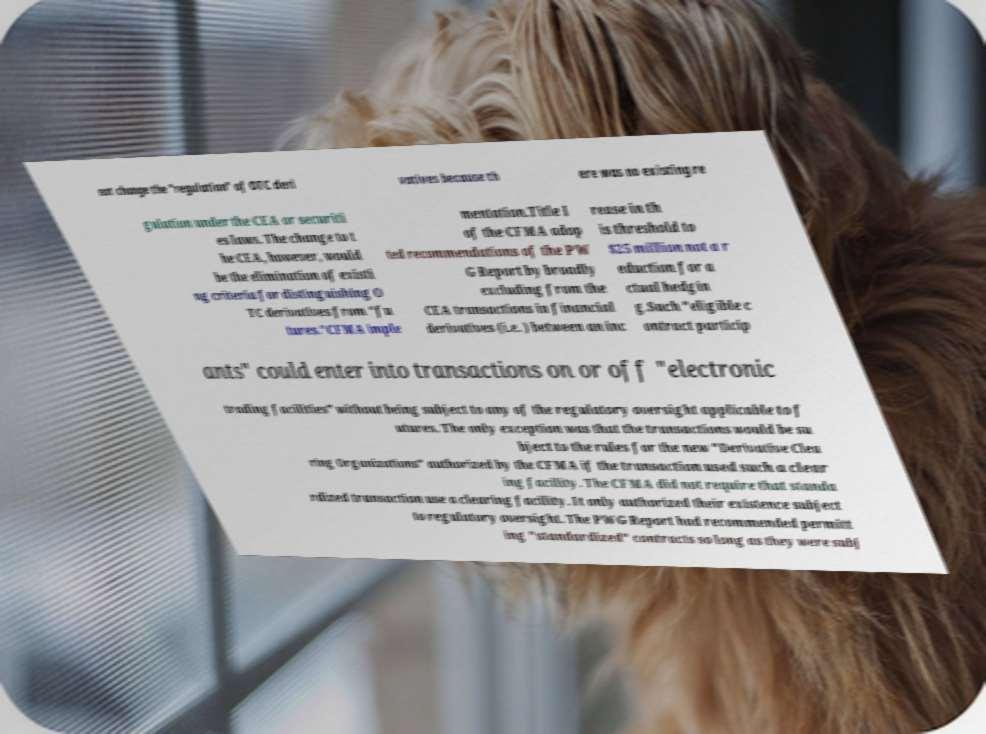What messages or text are displayed in this image? I need them in a readable, typed format. not change the "regulation" of OTC deri vatives because th ere was no existing re gulation under the CEA or securiti es laws. The change to t he CEA, however, would be the elimination of existi ng criteria for distinguishing O TC derivatives from "fu tures."CFMA imple mentation.Title I of the CFMA adop ted recommendations of the PW G Report by broadly excluding from the CEA transactions in financial derivatives (i.e. ) between an inc rease in th is threshold to $25 million not a r eduction for a ctual hedgin g.Such "eligible c ontract particip ants" could enter into transactions on or off "electronic trading facilities" without being subject to any of the regulatory oversight applicable to f utures. The only exception was that the transactions would be su bject to the rules for the new "Derivative Clea ring Organizations" authorized by the CFMA if the transaction used such a clear ing facility. The CFMA did not require that standa rdized transaction use a clearing facility. It only authorized their existence subject to regulatory oversight. The PWG Report had recommended permitt ing "standardized" contracts so long as they were subj 